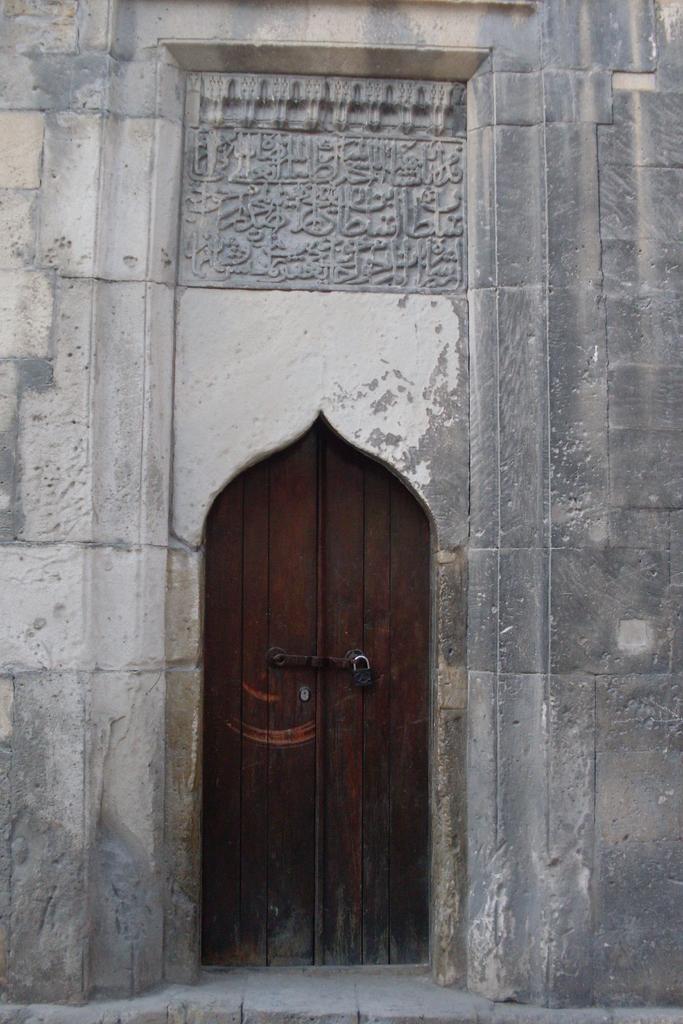How would you summarize this image in a sentence or two? In this image there is a building in the middle. At the bottom there is a door to which there is a lock. 